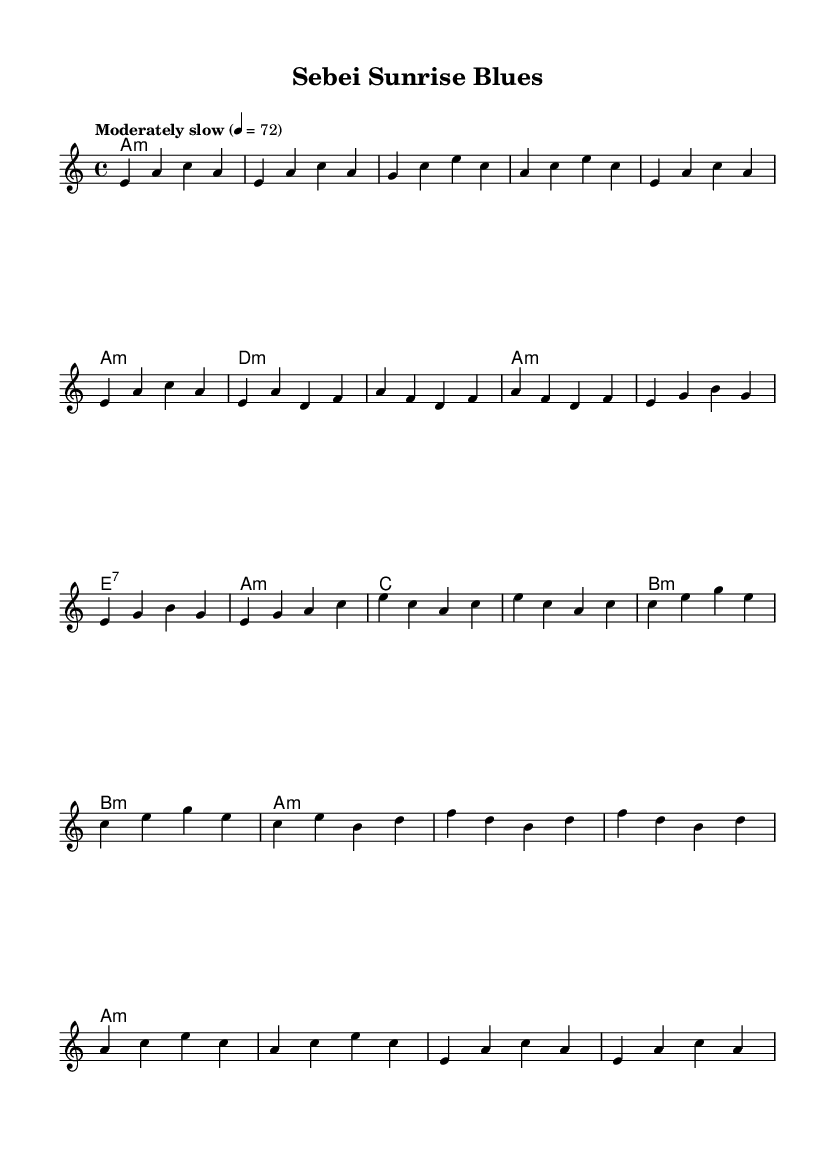What is the key signature of this music? The key signature is A minor, as indicated by the lack of sharps or flats alongside the presence of the note A at the beginning of the composition.
Answer: A minor What is the time signature of this music? The time signature is 4/4, which is noted at the beginning of the score and indicates there are four beats in each measure.
Answer: 4/4 What is the tempo marking for this piece? The tempo marking is "Moderately slow," with a metronome indication of 72 beats per minute. This suggests a relaxed pace for the music.
Answer: Moderately slow How many measures are in the introduction section? The introduction section consists of four measures, as seen when counting the bars before the verse begins.
Answer: 4 What type of blues progression is used in the harmonies? The harmonies follow a minor blues progression, which notably includes minor and seventh chords, typical of the blues genre.
Answer: Minor blues progression What is the note that starts the melody in the introduction? The first note of the melody in the introduction is E, as clearly marked in the musical notation at the start of the piece.
Answer: E How many times is the chord A minor indicated in the harmonies? The chord A minor appears six times throughout the harmonies section, making it a central focus of the piece.
Answer: 6 